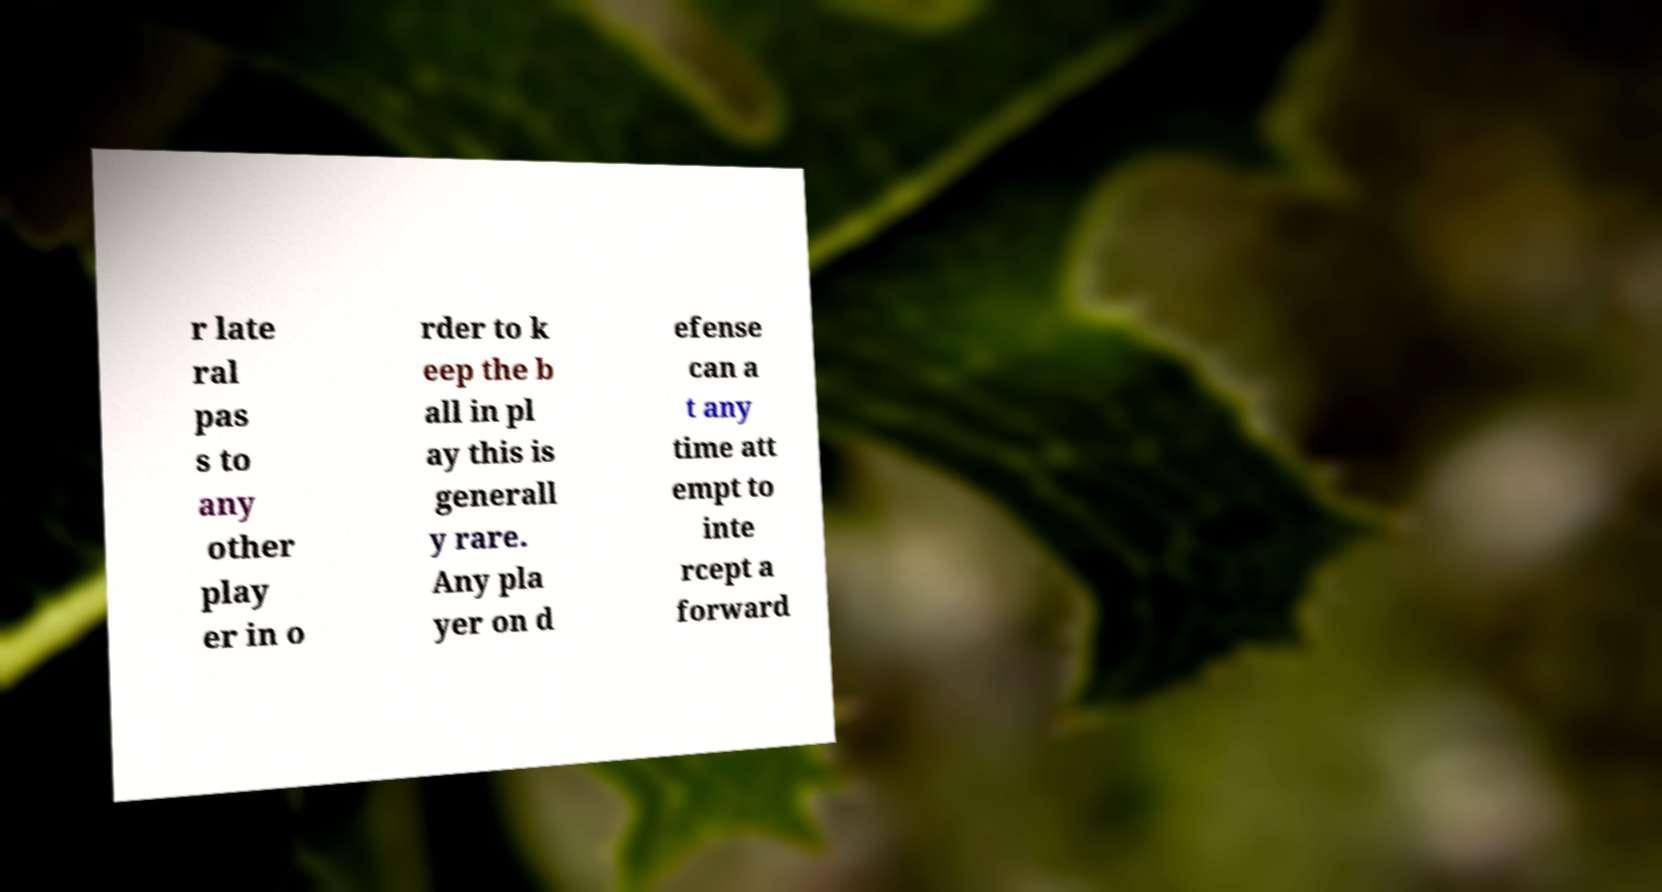For documentation purposes, I need the text within this image transcribed. Could you provide that? r late ral pas s to any other play er in o rder to k eep the b all in pl ay this is generall y rare. Any pla yer on d efense can a t any time att empt to inte rcept a forward 